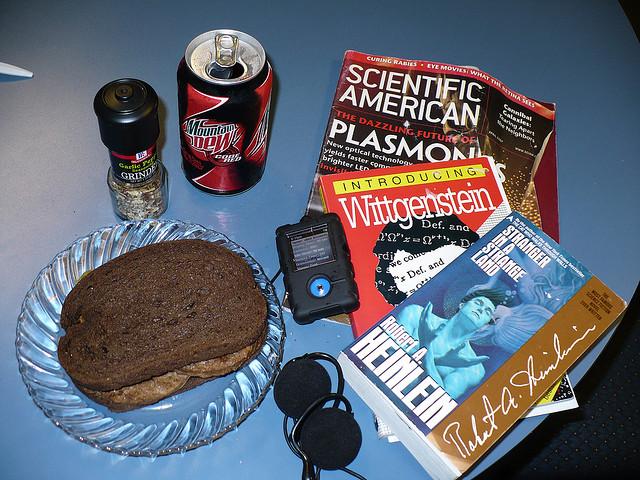How many books are there?
Answer briefly. 2. What beverage is on the table?
Answer briefly. Mountain dew. What kind of food is on the table?
Answer briefly. Sandwich. What are these for?
Answer briefly. Reading. Is the table top formica?
Be succinct. Yes. 